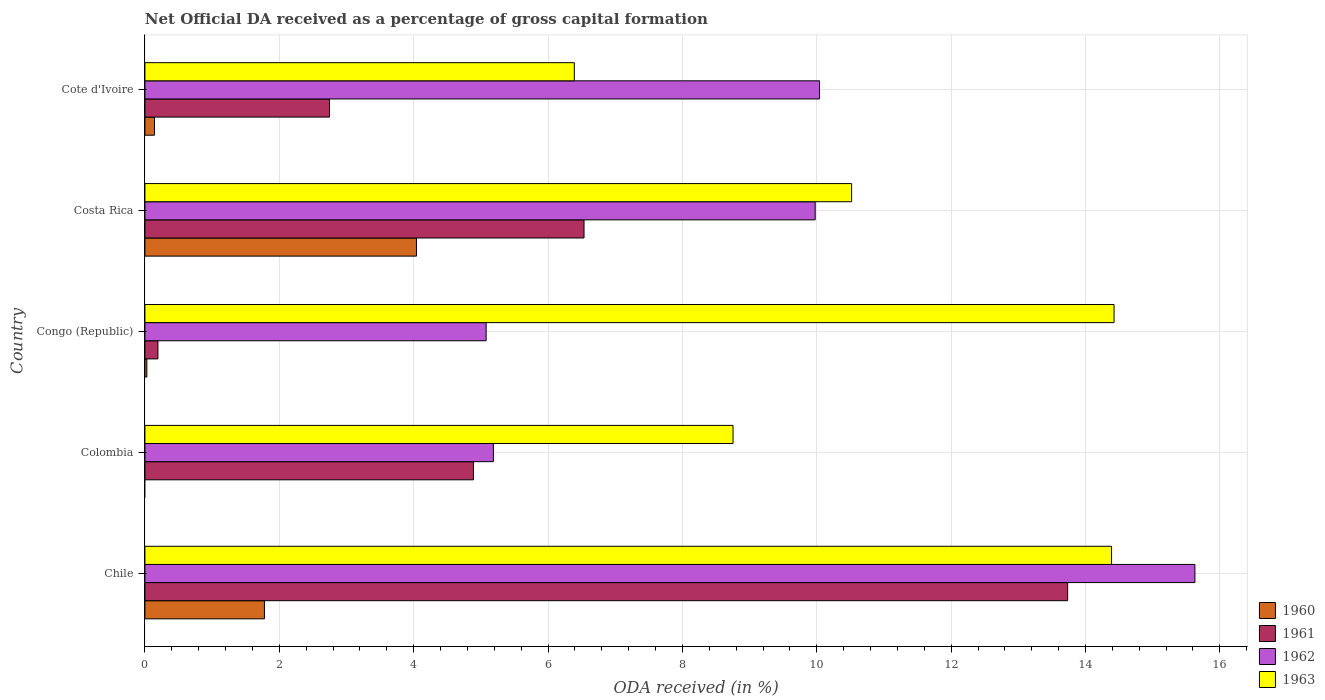Are the number of bars per tick equal to the number of legend labels?
Offer a terse response. No. How many bars are there on the 4th tick from the top?
Provide a succinct answer. 3. What is the label of the 2nd group of bars from the top?
Offer a very short reply. Costa Rica. What is the net ODA received in 1960 in Colombia?
Ensure brevity in your answer.  0. Across all countries, what is the maximum net ODA received in 1961?
Offer a very short reply. 13.73. Across all countries, what is the minimum net ODA received in 1961?
Ensure brevity in your answer.  0.19. What is the total net ODA received in 1962 in the graph?
Keep it short and to the point. 45.91. What is the difference between the net ODA received in 1963 in Costa Rica and that in Cote d'Ivoire?
Give a very brief answer. 4.13. What is the difference between the net ODA received in 1963 in Congo (Republic) and the net ODA received in 1961 in Costa Rica?
Keep it short and to the point. 7.89. What is the average net ODA received in 1962 per country?
Your response must be concise. 9.18. What is the difference between the net ODA received in 1963 and net ODA received in 1962 in Colombia?
Ensure brevity in your answer.  3.57. In how many countries, is the net ODA received in 1962 greater than 16 %?
Offer a terse response. 0. What is the ratio of the net ODA received in 1960 in Chile to that in Costa Rica?
Your answer should be compact. 0.44. What is the difference between the highest and the second highest net ODA received in 1960?
Provide a succinct answer. 2.26. What is the difference between the highest and the lowest net ODA received in 1960?
Keep it short and to the point. 4.04. Is the sum of the net ODA received in 1961 in Costa Rica and Cote d'Ivoire greater than the maximum net ODA received in 1962 across all countries?
Your answer should be very brief. No. Is it the case that in every country, the sum of the net ODA received in 1960 and net ODA received in 1963 is greater than the sum of net ODA received in 1961 and net ODA received in 1962?
Offer a very short reply. No. Is it the case that in every country, the sum of the net ODA received in 1960 and net ODA received in 1963 is greater than the net ODA received in 1961?
Give a very brief answer. Yes. What is the difference between two consecutive major ticks on the X-axis?
Offer a very short reply. 2. Are the values on the major ticks of X-axis written in scientific E-notation?
Provide a short and direct response. No. How many legend labels are there?
Your response must be concise. 4. How are the legend labels stacked?
Keep it short and to the point. Vertical. What is the title of the graph?
Offer a very short reply. Net Official DA received as a percentage of gross capital formation. What is the label or title of the X-axis?
Offer a very short reply. ODA received (in %). What is the ODA received (in %) of 1960 in Chile?
Give a very brief answer. 1.78. What is the ODA received (in %) of 1961 in Chile?
Make the answer very short. 13.73. What is the ODA received (in %) of 1962 in Chile?
Provide a short and direct response. 15.63. What is the ODA received (in %) of 1963 in Chile?
Ensure brevity in your answer.  14.39. What is the ODA received (in %) of 1960 in Colombia?
Your answer should be very brief. 0. What is the ODA received (in %) of 1961 in Colombia?
Make the answer very short. 4.89. What is the ODA received (in %) in 1962 in Colombia?
Provide a short and direct response. 5.19. What is the ODA received (in %) of 1963 in Colombia?
Keep it short and to the point. 8.75. What is the ODA received (in %) of 1960 in Congo (Republic)?
Your answer should be compact. 0.03. What is the ODA received (in %) of 1961 in Congo (Republic)?
Offer a terse response. 0.19. What is the ODA received (in %) of 1962 in Congo (Republic)?
Provide a short and direct response. 5.08. What is the ODA received (in %) in 1963 in Congo (Republic)?
Your response must be concise. 14.43. What is the ODA received (in %) in 1960 in Costa Rica?
Keep it short and to the point. 4.04. What is the ODA received (in %) in 1961 in Costa Rica?
Give a very brief answer. 6.54. What is the ODA received (in %) in 1962 in Costa Rica?
Offer a terse response. 9.98. What is the ODA received (in %) in 1963 in Costa Rica?
Your answer should be very brief. 10.52. What is the ODA received (in %) of 1960 in Cote d'Ivoire?
Give a very brief answer. 0.14. What is the ODA received (in %) in 1961 in Cote d'Ivoire?
Your answer should be compact. 2.75. What is the ODA received (in %) in 1962 in Cote d'Ivoire?
Give a very brief answer. 10.04. What is the ODA received (in %) in 1963 in Cote d'Ivoire?
Your answer should be very brief. 6.39. Across all countries, what is the maximum ODA received (in %) in 1960?
Ensure brevity in your answer.  4.04. Across all countries, what is the maximum ODA received (in %) in 1961?
Ensure brevity in your answer.  13.73. Across all countries, what is the maximum ODA received (in %) in 1962?
Your answer should be very brief. 15.63. Across all countries, what is the maximum ODA received (in %) of 1963?
Provide a short and direct response. 14.43. Across all countries, what is the minimum ODA received (in %) of 1960?
Your response must be concise. 0. Across all countries, what is the minimum ODA received (in %) of 1961?
Ensure brevity in your answer.  0.19. Across all countries, what is the minimum ODA received (in %) of 1962?
Your answer should be compact. 5.08. Across all countries, what is the minimum ODA received (in %) of 1963?
Make the answer very short. 6.39. What is the total ODA received (in %) in 1960 in the graph?
Provide a short and direct response. 5.99. What is the total ODA received (in %) in 1961 in the graph?
Provide a short and direct response. 28.1. What is the total ODA received (in %) of 1962 in the graph?
Your answer should be very brief. 45.91. What is the total ODA received (in %) of 1963 in the graph?
Make the answer very short. 54.48. What is the difference between the ODA received (in %) in 1961 in Chile and that in Colombia?
Ensure brevity in your answer.  8.84. What is the difference between the ODA received (in %) in 1962 in Chile and that in Colombia?
Provide a succinct answer. 10.44. What is the difference between the ODA received (in %) in 1963 in Chile and that in Colombia?
Offer a very short reply. 5.63. What is the difference between the ODA received (in %) in 1960 in Chile and that in Congo (Republic)?
Your answer should be compact. 1.75. What is the difference between the ODA received (in %) of 1961 in Chile and that in Congo (Republic)?
Your answer should be compact. 13.54. What is the difference between the ODA received (in %) in 1962 in Chile and that in Congo (Republic)?
Give a very brief answer. 10.55. What is the difference between the ODA received (in %) in 1963 in Chile and that in Congo (Republic)?
Make the answer very short. -0.04. What is the difference between the ODA received (in %) of 1960 in Chile and that in Costa Rica?
Your answer should be very brief. -2.26. What is the difference between the ODA received (in %) of 1961 in Chile and that in Costa Rica?
Offer a very short reply. 7.2. What is the difference between the ODA received (in %) in 1962 in Chile and that in Costa Rica?
Make the answer very short. 5.65. What is the difference between the ODA received (in %) in 1963 in Chile and that in Costa Rica?
Provide a short and direct response. 3.87. What is the difference between the ODA received (in %) of 1960 in Chile and that in Cote d'Ivoire?
Provide a short and direct response. 1.64. What is the difference between the ODA received (in %) in 1961 in Chile and that in Cote d'Ivoire?
Your answer should be very brief. 10.99. What is the difference between the ODA received (in %) of 1962 in Chile and that in Cote d'Ivoire?
Make the answer very short. 5.59. What is the difference between the ODA received (in %) of 1963 in Chile and that in Cote d'Ivoire?
Ensure brevity in your answer.  8. What is the difference between the ODA received (in %) in 1961 in Colombia and that in Congo (Republic)?
Keep it short and to the point. 4.7. What is the difference between the ODA received (in %) in 1962 in Colombia and that in Congo (Republic)?
Offer a very short reply. 0.11. What is the difference between the ODA received (in %) in 1963 in Colombia and that in Congo (Republic)?
Ensure brevity in your answer.  -5.67. What is the difference between the ODA received (in %) of 1961 in Colombia and that in Costa Rica?
Provide a succinct answer. -1.65. What is the difference between the ODA received (in %) of 1962 in Colombia and that in Costa Rica?
Provide a succinct answer. -4.79. What is the difference between the ODA received (in %) of 1963 in Colombia and that in Costa Rica?
Ensure brevity in your answer.  -1.76. What is the difference between the ODA received (in %) of 1961 in Colombia and that in Cote d'Ivoire?
Your answer should be compact. 2.14. What is the difference between the ODA received (in %) of 1962 in Colombia and that in Cote d'Ivoire?
Offer a very short reply. -4.86. What is the difference between the ODA received (in %) in 1963 in Colombia and that in Cote d'Ivoire?
Your answer should be compact. 2.36. What is the difference between the ODA received (in %) of 1960 in Congo (Republic) and that in Costa Rica?
Your answer should be very brief. -4.01. What is the difference between the ODA received (in %) in 1961 in Congo (Republic) and that in Costa Rica?
Offer a terse response. -6.34. What is the difference between the ODA received (in %) of 1962 in Congo (Republic) and that in Costa Rica?
Offer a terse response. -4.9. What is the difference between the ODA received (in %) in 1963 in Congo (Republic) and that in Costa Rica?
Give a very brief answer. 3.91. What is the difference between the ODA received (in %) of 1960 in Congo (Republic) and that in Cote d'Ivoire?
Give a very brief answer. -0.11. What is the difference between the ODA received (in %) in 1961 in Congo (Republic) and that in Cote d'Ivoire?
Ensure brevity in your answer.  -2.55. What is the difference between the ODA received (in %) of 1962 in Congo (Republic) and that in Cote d'Ivoire?
Your response must be concise. -4.96. What is the difference between the ODA received (in %) in 1963 in Congo (Republic) and that in Cote d'Ivoire?
Keep it short and to the point. 8.03. What is the difference between the ODA received (in %) of 1960 in Costa Rica and that in Cote d'Ivoire?
Your answer should be compact. 3.9. What is the difference between the ODA received (in %) of 1961 in Costa Rica and that in Cote d'Ivoire?
Your response must be concise. 3.79. What is the difference between the ODA received (in %) of 1962 in Costa Rica and that in Cote d'Ivoire?
Give a very brief answer. -0.06. What is the difference between the ODA received (in %) in 1963 in Costa Rica and that in Cote d'Ivoire?
Ensure brevity in your answer.  4.13. What is the difference between the ODA received (in %) in 1960 in Chile and the ODA received (in %) in 1961 in Colombia?
Ensure brevity in your answer.  -3.11. What is the difference between the ODA received (in %) in 1960 in Chile and the ODA received (in %) in 1962 in Colombia?
Make the answer very short. -3.41. What is the difference between the ODA received (in %) of 1960 in Chile and the ODA received (in %) of 1963 in Colombia?
Offer a very short reply. -6.97. What is the difference between the ODA received (in %) in 1961 in Chile and the ODA received (in %) in 1962 in Colombia?
Keep it short and to the point. 8.55. What is the difference between the ODA received (in %) of 1961 in Chile and the ODA received (in %) of 1963 in Colombia?
Offer a very short reply. 4.98. What is the difference between the ODA received (in %) in 1962 in Chile and the ODA received (in %) in 1963 in Colombia?
Offer a terse response. 6.88. What is the difference between the ODA received (in %) of 1960 in Chile and the ODA received (in %) of 1961 in Congo (Republic)?
Your response must be concise. 1.59. What is the difference between the ODA received (in %) in 1960 in Chile and the ODA received (in %) in 1962 in Congo (Republic)?
Offer a terse response. -3.3. What is the difference between the ODA received (in %) in 1960 in Chile and the ODA received (in %) in 1963 in Congo (Republic)?
Give a very brief answer. -12.65. What is the difference between the ODA received (in %) of 1961 in Chile and the ODA received (in %) of 1962 in Congo (Republic)?
Your response must be concise. 8.66. What is the difference between the ODA received (in %) of 1961 in Chile and the ODA received (in %) of 1963 in Congo (Republic)?
Ensure brevity in your answer.  -0.69. What is the difference between the ODA received (in %) in 1962 in Chile and the ODA received (in %) in 1963 in Congo (Republic)?
Offer a terse response. 1.2. What is the difference between the ODA received (in %) of 1960 in Chile and the ODA received (in %) of 1961 in Costa Rica?
Offer a terse response. -4.76. What is the difference between the ODA received (in %) of 1960 in Chile and the ODA received (in %) of 1962 in Costa Rica?
Provide a succinct answer. -8.2. What is the difference between the ODA received (in %) of 1960 in Chile and the ODA received (in %) of 1963 in Costa Rica?
Give a very brief answer. -8.74. What is the difference between the ODA received (in %) of 1961 in Chile and the ODA received (in %) of 1962 in Costa Rica?
Your answer should be compact. 3.76. What is the difference between the ODA received (in %) in 1961 in Chile and the ODA received (in %) in 1963 in Costa Rica?
Your response must be concise. 3.22. What is the difference between the ODA received (in %) of 1962 in Chile and the ODA received (in %) of 1963 in Costa Rica?
Your response must be concise. 5.11. What is the difference between the ODA received (in %) in 1960 in Chile and the ODA received (in %) in 1961 in Cote d'Ivoire?
Ensure brevity in your answer.  -0.97. What is the difference between the ODA received (in %) in 1960 in Chile and the ODA received (in %) in 1962 in Cote d'Ivoire?
Give a very brief answer. -8.26. What is the difference between the ODA received (in %) in 1960 in Chile and the ODA received (in %) in 1963 in Cote d'Ivoire?
Your response must be concise. -4.61. What is the difference between the ODA received (in %) of 1961 in Chile and the ODA received (in %) of 1962 in Cote d'Ivoire?
Make the answer very short. 3.69. What is the difference between the ODA received (in %) in 1961 in Chile and the ODA received (in %) in 1963 in Cote d'Ivoire?
Offer a very short reply. 7.34. What is the difference between the ODA received (in %) in 1962 in Chile and the ODA received (in %) in 1963 in Cote d'Ivoire?
Offer a very short reply. 9.24. What is the difference between the ODA received (in %) in 1961 in Colombia and the ODA received (in %) in 1962 in Congo (Republic)?
Make the answer very short. -0.19. What is the difference between the ODA received (in %) of 1961 in Colombia and the ODA received (in %) of 1963 in Congo (Republic)?
Your answer should be compact. -9.54. What is the difference between the ODA received (in %) in 1962 in Colombia and the ODA received (in %) in 1963 in Congo (Republic)?
Your answer should be compact. -9.24. What is the difference between the ODA received (in %) in 1961 in Colombia and the ODA received (in %) in 1962 in Costa Rica?
Your answer should be very brief. -5.09. What is the difference between the ODA received (in %) of 1961 in Colombia and the ODA received (in %) of 1963 in Costa Rica?
Provide a short and direct response. -5.63. What is the difference between the ODA received (in %) in 1962 in Colombia and the ODA received (in %) in 1963 in Costa Rica?
Ensure brevity in your answer.  -5.33. What is the difference between the ODA received (in %) of 1961 in Colombia and the ODA received (in %) of 1962 in Cote d'Ivoire?
Ensure brevity in your answer.  -5.15. What is the difference between the ODA received (in %) of 1961 in Colombia and the ODA received (in %) of 1963 in Cote d'Ivoire?
Keep it short and to the point. -1.5. What is the difference between the ODA received (in %) in 1962 in Colombia and the ODA received (in %) in 1963 in Cote d'Ivoire?
Make the answer very short. -1.2. What is the difference between the ODA received (in %) in 1960 in Congo (Republic) and the ODA received (in %) in 1961 in Costa Rica?
Your response must be concise. -6.51. What is the difference between the ODA received (in %) of 1960 in Congo (Republic) and the ODA received (in %) of 1962 in Costa Rica?
Provide a succinct answer. -9.95. What is the difference between the ODA received (in %) in 1960 in Congo (Republic) and the ODA received (in %) in 1963 in Costa Rica?
Provide a succinct answer. -10.49. What is the difference between the ODA received (in %) of 1961 in Congo (Republic) and the ODA received (in %) of 1962 in Costa Rica?
Your response must be concise. -9.78. What is the difference between the ODA received (in %) of 1961 in Congo (Republic) and the ODA received (in %) of 1963 in Costa Rica?
Your answer should be compact. -10.32. What is the difference between the ODA received (in %) of 1962 in Congo (Republic) and the ODA received (in %) of 1963 in Costa Rica?
Make the answer very short. -5.44. What is the difference between the ODA received (in %) in 1960 in Congo (Republic) and the ODA received (in %) in 1961 in Cote d'Ivoire?
Your response must be concise. -2.72. What is the difference between the ODA received (in %) of 1960 in Congo (Republic) and the ODA received (in %) of 1962 in Cote d'Ivoire?
Ensure brevity in your answer.  -10.01. What is the difference between the ODA received (in %) in 1960 in Congo (Republic) and the ODA received (in %) in 1963 in Cote d'Ivoire?
Ensure brevity in your answer.  -6.36. What is the difference between the ODA received (in %) in 1961 in Congo (Republic) and the ODA received (in %) in 1962 in Cote d'Ivoire?
Provide a succinct answer. -9.85. What is the difference between the ODA received (in %) of 1961 in Congo (Republic) and the ODA received (in %) of 1963 in Cote d'Ivoire?
Provide a succinct answer. -6.2. What is the difference between the ODA received (in %) in 1962 in Congo (Republic) and the ODA received (in %) in 1963 in Cote d'Ivoire?
Make the answer very short. -1.31. What is the difference between the ODA received (in %) of 1960 in Costa Rica and the ODA received (in %) of 1961 in Cote d'Ivoire?
Provide a succinct answer. 1.29. What is the difference between the ODA received (in %) in 1960 in Costa Rica and the ODA received (in %) in 1962 in Cote d'Ivoire?
Offer a terse response. -6. What is the difference between the ODA received (in %) of 1960 in Costa Rica and the ODA received (in %) of 1963 in Cote d'Ivoire?
Make the answer very short. -2.35. What is the difference between the ODA received (in %) in 1961 in Costa Rica and the ODA received (in %) in 1962 in Cote d'Ivoire?
Keep it short and to the point. -3.51. What is the difference between the ODA received (in %) in 1961 in Costa Rica and the ODA received (in %) in 1963 in Cote d'Ivoire?
Your answer should be very brief. 0.14. What is the difference between the ODA received (in %) in 1962 in Costa Rica and the ODA received (in %) in 1963 in Cote d'Ivoire?
Make the answer very short. 3.59. What is the average ODA received (in %) in 1960 per country?
Your answer should be very brief. 1.2. What is the average ODA received (in %) in 1961 per country?
Give a very brief answer. 5.62. What is the average ODA received (in %) of 1962 per country?
Your answer should be very brief. 9.18. What is the average ODA received (in %) in 1963 per country?
Ensure brevity in your answer.  10.9. What is the difference between the ODA received (in %) in 1960 and ODA received (in %) in 1961 in Chile?
Your answer should be very brief. -11.96. What is the difference between the ODA received (in %) in 1960 and ODA received (in %) in 1962 in Chile?
Make the answer very short. -13.85. What is the difference between the ODA received (in %) of 1960 and ODA received (in %) of 1963 in Chile?
Your answer should be very brief. -12.61. What is the difference between the ODA received (in %) in 1961 and ODA received (in %) in 1962 in Chile?
Ensure brevity in your answer.  -1.89. What is the difference between the ODA received (in %) of 1961 and ODA received (in %) of 1963 in Chile?
Your answer should be compact. -0.65. What is the difference between the ODA received (in %) in 1962 and ODA received (in %) in 1963 in Chile?
Give a very brief answer. 1.24. What is the difference between the ODA received (in %) of 1961 and ODA received (in %) of 1962 in Colombia?
Make the answer very short. -0.3. What is the difference between the ODA received (in %) of 1961 and ODA received (in %) of 1963 in Colombia?
Your answer should be very brief. -3.86. What is the difference between the ODA received (in %) in 1962 and ODA received (in %) in 1963 in Colombia?
Your answer should be very brief. -3.57. What is the difference between the ODA received (in %) of 1960 and ODA received (in %) of 1961 in Congo (Republic)?
Make the answer very short. -0.17. What is the difference between the ODA received (in %) of 1960 and ODA received (in %) of 1962 in Congo (Republic)?
Your response must be concise. -5.05. What is the difference between the ODA received (in %) of 1960 and ODA received (in %) of 1963 in Congo (Republic)?
Ensure brevity in your answer.  -14.4. What is the difference between the ODA received (in %) in 1961 and ODA received (in %) in 1962 in Congo (Republic)?
Keep it short and to the point. -4.89. What is the difference between the ODA received (in %) of 1961 and ODA received (in %) of 1963 in Congo (Republic)?
Your response must be concise. -14.23. What is the difference between the ODA received (in %) in 1962 and ODA received (in %) in 1963 in Congo (Republic)?
Provide a short and direct response. -9.35. What is the difference between the ODA received (in %) in 1960 and ODA received (in %) in 1961 in Costa Rica?
Your answer should be compact. -2.49. What is the difference between the ODA received (in %) of 1960 and ODA received (in %) of 1962 in Costa Rica?
Provide a short and direct response. -5.93. What is the difference between the ODA received (in %) in 1960 and ODA received (in %) in 1963 in Costa Rica?
Ensure brevity in your answer.  -6.48. What is the difference between the ODA received (in %) in 1961 and ODA received (in %) in 1962 in Costa Rica?
Give a very brief answer. -3.44. What is the difference between the ODA received (in %) of 1961 and ODA received (in %) of 1963 in Costa Rica?
Give a very brief answer. -3.98. What is the difference between the ODA received (in %) of 1962 and ODA received (in %) of 1963 in Costa Rica?
Offer a very short reply. -0.54. What is the difference between the ODA received (in %) in 1960 and ODA received (in %) in 1961 in Cote d'Ivoire?
Your answer should be very brief. -2.6. What is the difference between the ODA received (in %) of 1960 and ODA received (in %) of 1962 in Cote d'Ivoire?
Make the answer very short. -9.9. What is the difference between the ODA received (in %) of 1960 and ODA received (in %) of 1963 in Cote d'Ivoire?
Keep it short and to the point. -6.25. What is the difference between the ODA received (in %) of 1961 and ODA received (in %) of 1962 in Cote d'Ivoire?
Provide a short and direct response. -7.29. What is the difference between the ODA received (in %) in 1961 and ODA received (in %) in 1963 in Cote d'Ivoire?
Ensure brevity in your answer.  -3.64. What is the difference between the ODA received (in %) in 1962 and ODA received (in %) in 1963 in Cote d'Ivoire?
Provide a succinct answer. 3.65. What is the ratio of the ODA received (in %) of 1961 in Chile to that in Colombia?
Your answer should be very brief. 2.81. What is the ratio of the ODA received (in %) of 1962 in Chile to that in Colombia?
Ensure brevity in your answer.  3.01. What is the ratio of the ODA received (in %) in 1963 in Chile to that in Colombia?
Offer a very short reply. 1.64. What is the ratio of the ODA received (in %) in 1960 in Chile to that in Congo (Republic)?
Keep it short and to the point. 62.32. What is the ratio of the ODA received (in %) in 1961 in Chile to that in Congo (Republic)?
Your answer should be very brief. 70.89. What is the ratio of the ODA received (in %) in 1962 in Chile to that in Congo (Republic)?
Make the answer very short. 3.08. What is the ratio of the ODA received (in %) in 1960 in Chile to that in Costa Rica?
Make the answer very short. 0.44. What is the ratio of the ODA received (in %) of 1961 in Chile to that in Costa Rica?
Ensure brevity in your answer.  2.1. What is the ratio of the ODA received (in %) in 1962 in Chile to that in Costa Rica?
Keep it short and to the point. 1.57. What is the ratio of the ODA received (in %) of 1963 in Chile to that in Costa Rica?
Your response must be concise. 1.37. What is the ratio of the ODA received (in %) of 1960 in Chile to that in Cote d'Ivoire?
Your answer should be compact. 12.5. What is the ratio of the ODA received (in %) of 1961 in Chile to that in Cote d'Ivoire?
Your answer should be compact. 5. What is the ratio of the ODA received (in %) in 1962 in Chile to that in Cote d'Ivoire?
Give a very brief answer. 1.56. What is the ratio of the ODA received (in %) of 1963 in Chile to that in Cote d'Ivoire?
Make the answer very short. 2.25. What is the ratio of the ODA received (in %) of 1961 in Colombia to that in Congo (Republic)?
Your response must be concise. 25.24. What is the ratio of the ODA received (in %) in 1962 in Colombia to that in Congo (Republic)?
Provide a succinct answer. 1.02. What is the ratio of the ODA received (in %) of 1963 in Colombia to that in Congo (Republic)?
Provide a short and direct response. 0.61. What is the ratio of the ODA received (in %) of 1961 in Colombia to that in Costa Rica?
Offer a very short reply. 0.75. What is the ratio of the ODA received (in %) of 1962 in Colombia to that in Costa Rica?
Ensure brevity in your answer.  0.52. What is the ratio of the ODA received (in %) of 1963 in Colombia to that in Costa Rica?
Make the answer very short. 0.83. What is the ratio of the ODA received (in %) in 1961 in Colombia to that in Cote d'Ivoire?
Give a very brief answer. 1.78. What is the ratio of the ODA received (in %) of 1962 in Colombia to that in Cote d'Ivoire?
Provide a succinct answer. 0.52. What is the ratio of the ODA received (in %) of 1963 in Colombia to that in Cote d'Ivoire?
Offer a terse response. 1.37. What is the ratio of the ODA received (in %) in 1960 in Congo (Republic) to that in Costa Rica?
Provide a succinct answer. 0.01. What is the ratio of the ODA received (in %) of 1961 in Congo (Republic) to that in Costa Rica?
Provide a short and direct response. 0.03. What is the ratio of the ODA received (in %) in 1962 in Congo (Republic) to that in Costa Rica?
Your answer should be compact. 0.51. What is the ratio of the ODA received (in %) of 1963 in Congo (Republic) to that in Costa Rica?
Provide a succinct answer. 1.37. What is the ratio of the ODA received (in %) of 1960 in Congo (Republic) to that in Cote d'Ivoire?
Provide a succinct answer. 0.2. What is the ratio of the ODA received (in %) in 1961 in Congo (Republic) to that in Cote d'Ivoire?
Offer a terse response. 0.07. What is the ratio of the ODA received (in %) of 1962 in Congo (Republic) to that in Cote d'Ivoire?
Your answer should be very brief. 0.51. What is the ratio of the ODA received (in %) in 1963 in Congo (Republic) to that in Cote d'Ivoire?
Provide a short and direct response. 2.26. What is the ratio of the ODA received (in %) in 1960 in Costa Rica to that in Cote d'Ivoire?
Provide a short and direct response. 28.4. What is the ratio of the ODA received (in %) in 1961 in Costa Rica to that in Cote d'Ivoire?
Offer a terse response. 2.38. What is the ratio of the ODA received (in %) in 1962 in Costa Rica to that in Cote d'Ivoire?
Keep it short and to the point. 0.99. What is the ratio of the ODA received (in %) of 1963 in Costa Rica to that in Cote d'Ivoire?
Give a very brief answer. 1.65. What is the difference between the highest and the second highest ODA received (in %) in 1960?
Your answer should be compact. 2.26. What is the difference between the highest and the second highest ODA received (in %) of 1961?
Make the answer very short. 7.2. What is the difference between the highest and the second highest ODA received (in %) in 1962?
Offer a very short reply. 5.59. What is the difference between the highest and the second highest ODA received (in %) of 1963?
Give a very brief answer. 0.04. What is the difference between the highest and the lowest ODA received (in %) of 1960?
Provide a succinct answer. 4.04. What is the difference between the highest and the lowest ODA received (in %) of 1961?
Make the answer very short. 13.54. What is the difference between the highest and the lowest ODA received (in %) in 1962?
Your answer should be compact. 10.55. What is the difference between the highest and the lowest ODA received (in %) in 1963?
Provide a succinct answer. 8.03. 